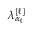<formula> <loc_0><loc_0><loc_500><loc_500>\lambda _ { \alpha _ { \ell } } ^ { [ \ell ] }</formula> 